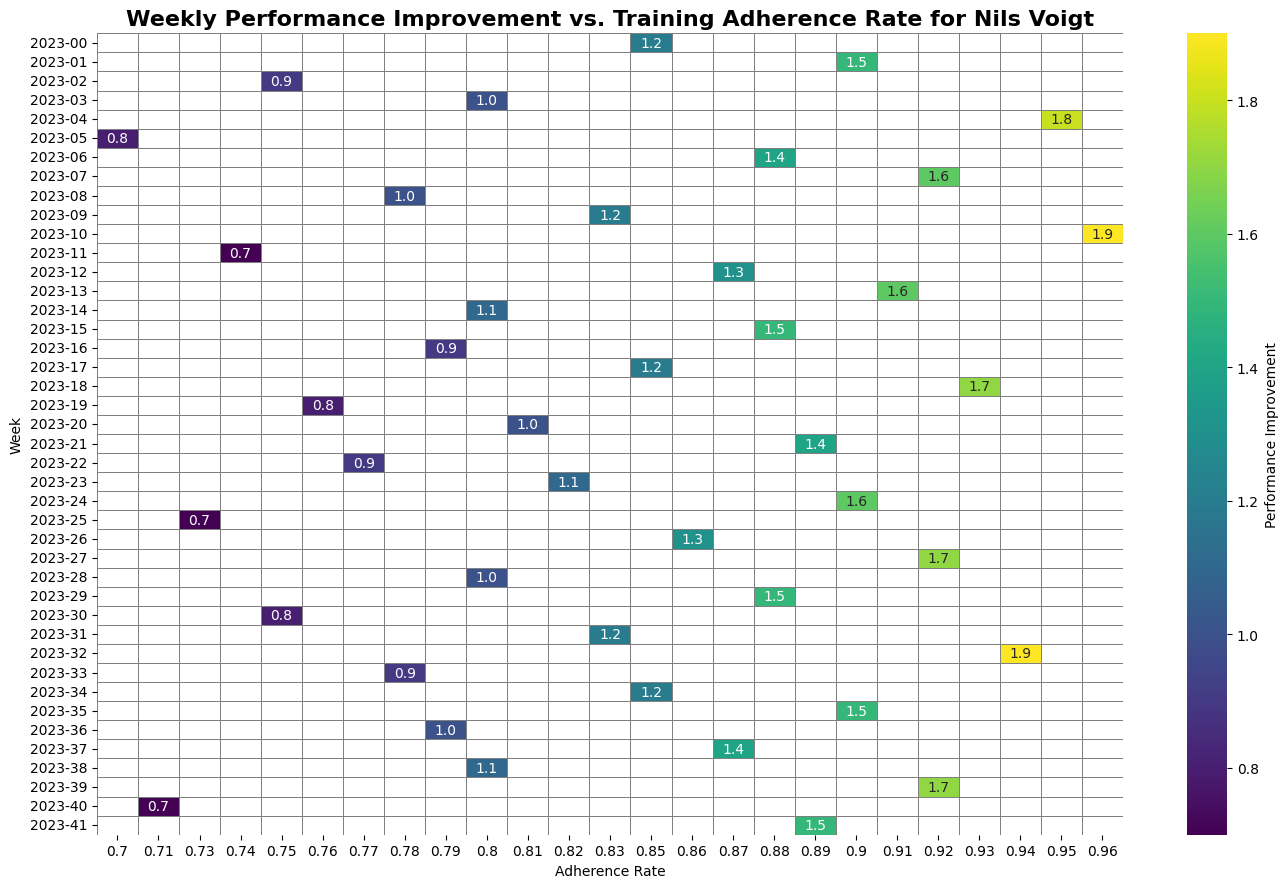Is there a specific adherence rate that generally shows the highest performance improvement? To identify this, observe the adherence rate labels on the horizontal axis and look for the column with the highest average annotations (performance improvements). The column labeled 0.96 shows the highest values, indicating a peak performance improvement of 1.9.
Answer: 0.96 What's the average performance improvement for the week of 2023-09-03? Locate the row labeled with the week 2023-36 on the vertical axis. The only annotation for that week under adherence rate 0.90 is 1.5. Therefore, the average performance improvement for that week is 1.5.
Answer: 1.5 Which week had the lowest performance improvement when the adherence rate was 0.71? Identify the column labeled 0.71 and find the week with the lowest value. The lowest value of 0.7 occurs in the week of 2023-40.
Answer: 2023-40 How does the performance improvement for adherence rate 0.85 compare between the first and last weeks of the study? Look at the column labeled 0.85 and compare the values from the first week (2023-01-01) and the last week (2023-10-15). For the week 2023-01-01, the performance improvement is 1.2, and for the week 2023-10-15, it is missing as adherence rate 0.85 is not available for that week. Therefore, there cannot be a direct comparison for both weeks simultaneously.
Answer: Incomparable What is the median performance improvement for adherence rates between 0.80 and 0.90 across all weeks? First, collect all performance improvements for adherence rates 0.80, 0.83, 0.85, 0.88, and 0.90 from the columns. These are: 1.0, 1.1, 1.0, 0.8, 1.2, 1.1, 1.2, 1.4, 1.3, 1.0, 1.1, 1.6, 1.6, 1.0, 1.5. Arranging these values in ascending order: 0.8, 1.0, 1.0, 1.0, 1.1, 1.1, 1.1, 1.2, 1.2, 1.3, 1.4, 1.5, 1.6, 1.6. The median value for this data set is calculated based on the middle entries for an odd number, resulting in 1.1.
Answer: 1.1 Which adherence rate shows more than one instance of performance improvement above 1.5? Check each adherence rate column to find instances where performance improvement exceeds 1.5 more than once. Columns 0.90 and 0.92 show multiple values above 1.5.
Answer: 0.90 and 0.92 How many weeks show a performance improvement of exactly 1.0? Count the occurrences of the value 1.0 across the entire heatmap, applicable for various adherence rates and weeks. There are 4 weeks (2023-01-22, 2023-02-26, 2023-04-09, 2023-07-16, and 2023-09-10).
Answer: 4 During which weeks did adherence rates of 0.75 and 0.77 have the same performance improvement? Identify all instances within the 0.75 and 0.77 columns where performance improvements are equal. Both adherence rates concurrently report performance improvements of 0.9 in the week 2023-02-26.
Answer: 2023-02-26 Which adherence rate had a consistent performance improvement of 1.2 four times during the study period? Traverse adherence rate columns to count how many times the value of 1.2 occurs in individual columns. Adherence rates 0.83, and 0.85 each have the value of 1.2 recorded four times.
Answer: 0.83 and 0.85 